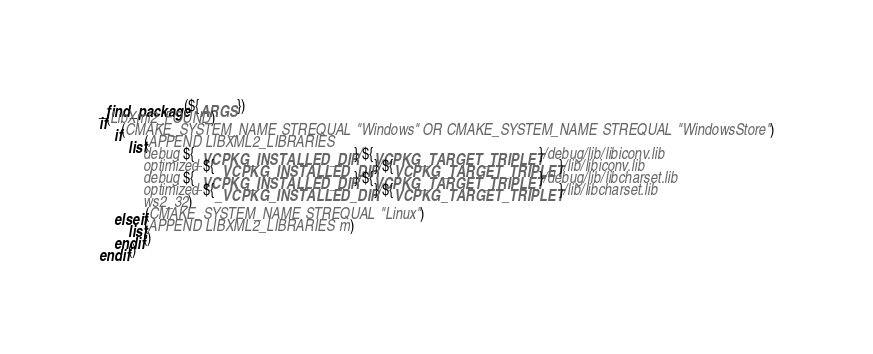<code> <loc_0><loc_0><loc_500><loc_500><_CMake_>_find_package(${ARGS})
if(LibXml2_FOUND)
    if(CMAKE_SYSTEM_NAME STREQUAL "Windows" OR CMAKE_SYSTEM_NAME STREQUAL "WindowsStore")
        list(APPEND LIBXML2_LIBRARIES
            debug ${_VCPKG_INSTALLED_DIR}/${VCPKG_TARGET_TRIPLET}/debug/lib/libiconv.lib
            optimized ${_VCPKG_INSTALLED_DIR}/${VCPKG_TARGET_TRIPLET}/lib/libiconv.lib
            debug ${_VCPKG_INSTALLED_DIR}/${VCPKG_TARGET_TRIPLET}/debug/lib/libcharset.lib
            optimized ${_VCPKG_INSTALLED_DIR}/${VCPKG_TARGET_TRIPLET}/lib/libcharset.lib
            ws2_32)
    elseif(CMAKE_SYSTEM_NAME STREQUAL "Linux")
        list(APPEND LIBXML2_LIBRARIES m)
    endif()
endif()
</code> 